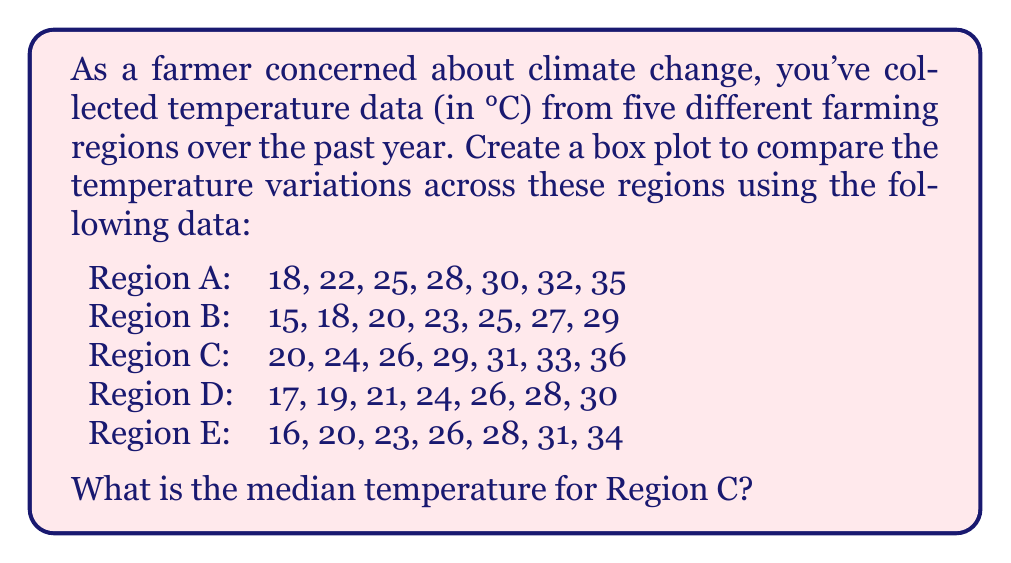Solve this math problem. To create a box plot and find the median temperature for Region C, we'll follow these steps:

1. Organize the data for each region in ascending order (already done in the question).

2. For Region C, we have: 20, 24, 26, 29, 31, 33, 36

3. To find the median, we need to identify the middle value in the ordered dataset.

4. Since there are 7 data points (an odd number), the median is the 4th value ($(n+1)/2 = (7+1)/2 = 4$).

5. The 4th value in the ordered dataset for Region C is 29.

6. To create the box plot, we would need to calculate the following for each region:
   - Minimum value (Q0)
   - First quartile (Q1)
   - Median (Q2)
   - Third quartile (Q3)
   - Maximum value (Q4)

7. For Region C:
   - Q0 (min) = 20
   - Q1 = 24
   - Q2 (median) = 29
   - Q3 = 33
   - Q4 (max) = 36

8. The box plot would be constructed using these values, with the box representing Q1 to Q3, a line inside the box for the median, and whiskers extending to the minimum and maximum values.

However, the specific question asks for the median temperature of Region C, which we've determined to be 29°C.
Answer: 29°C 